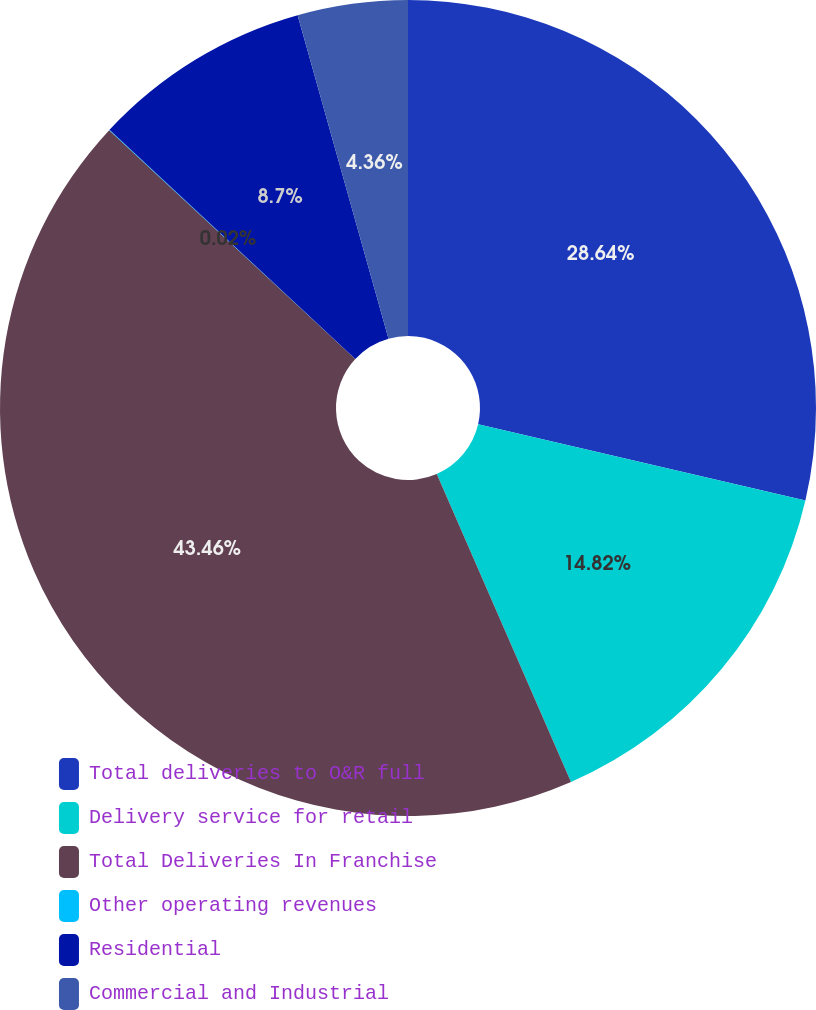Convert chart. <chart><loc_0><loc_0><loc_500><loc_500><pie_chart><fcel>Total deliveries to O&R full<fcel>Delivery service for retail<fcel>Total Deliveries In Franchise<fcel>Other operating revenues<fcel>Residential<fcel>Commercial and Industrial<nl><fcel>28.64%<fcel>14.82%<fcel>43.46%<fcel>0.02%<fcel>8.7%<fcel>4.36%<nl></chart> 